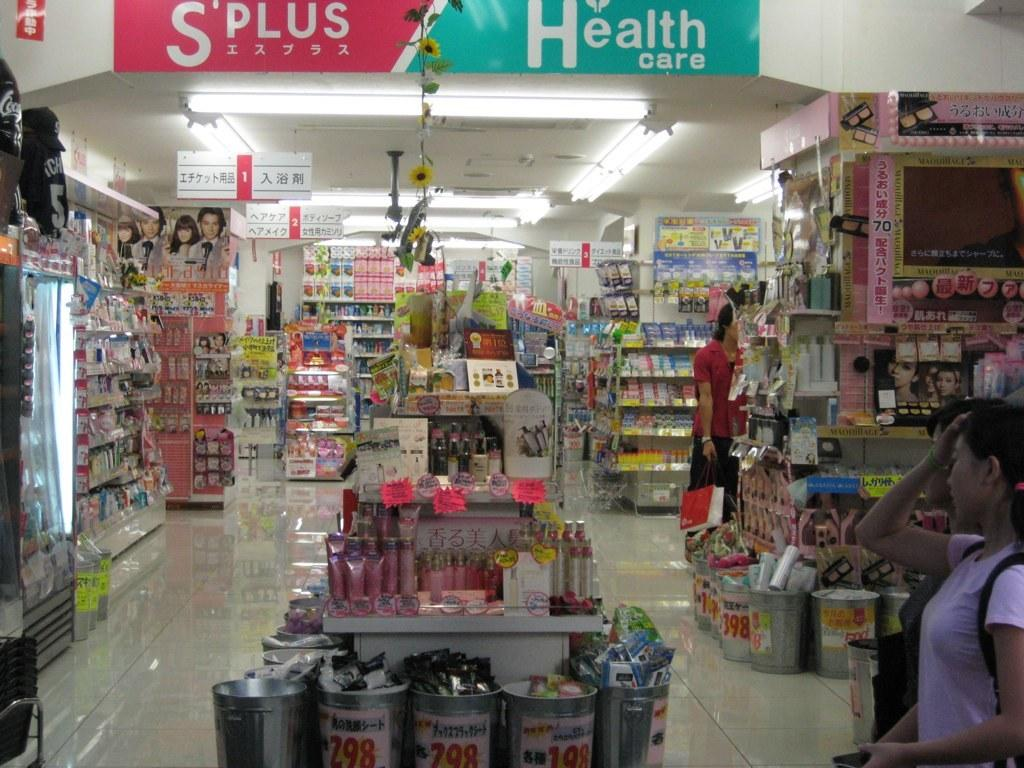<image>
Create a compact narrative representing the image presented. A woman walking in a store displaying a banner advertising Health care 